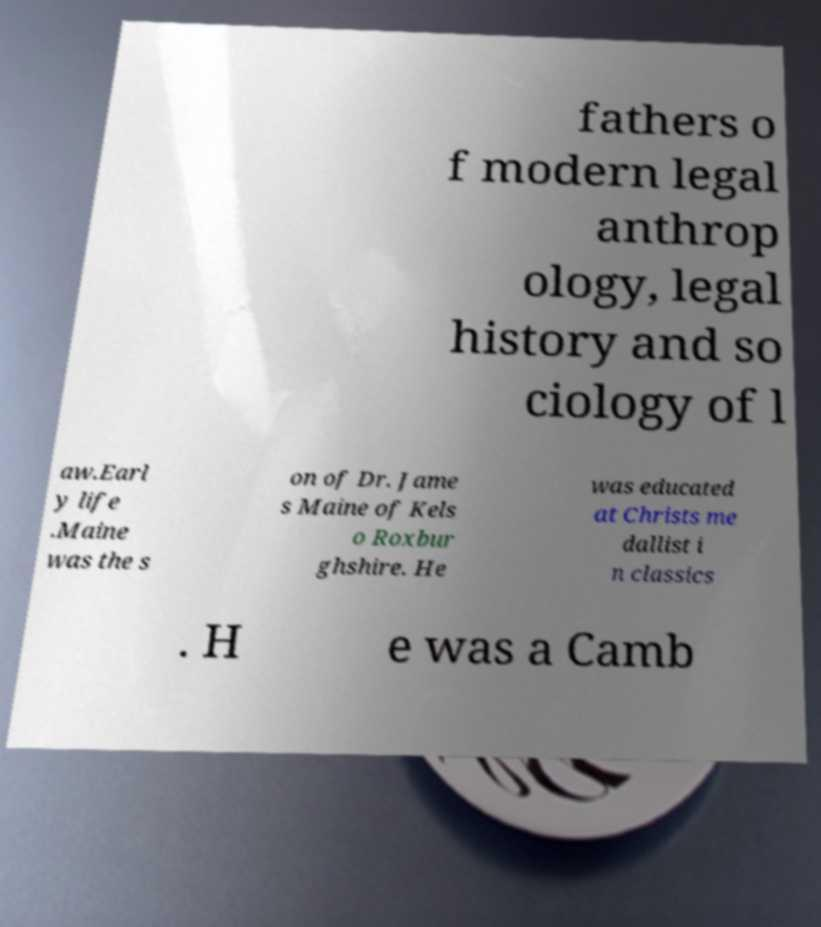Please read and relay the text visible in this image. What does it say? fathers o f modern legal anthrop ology, legal history and so ciology of l aw.Earl y life .Maine was the s on of Dr. Jame s Maine of Kels o Roxbur ghshire. He was educated at Christs me dallist i n classics . H e was a Camb 